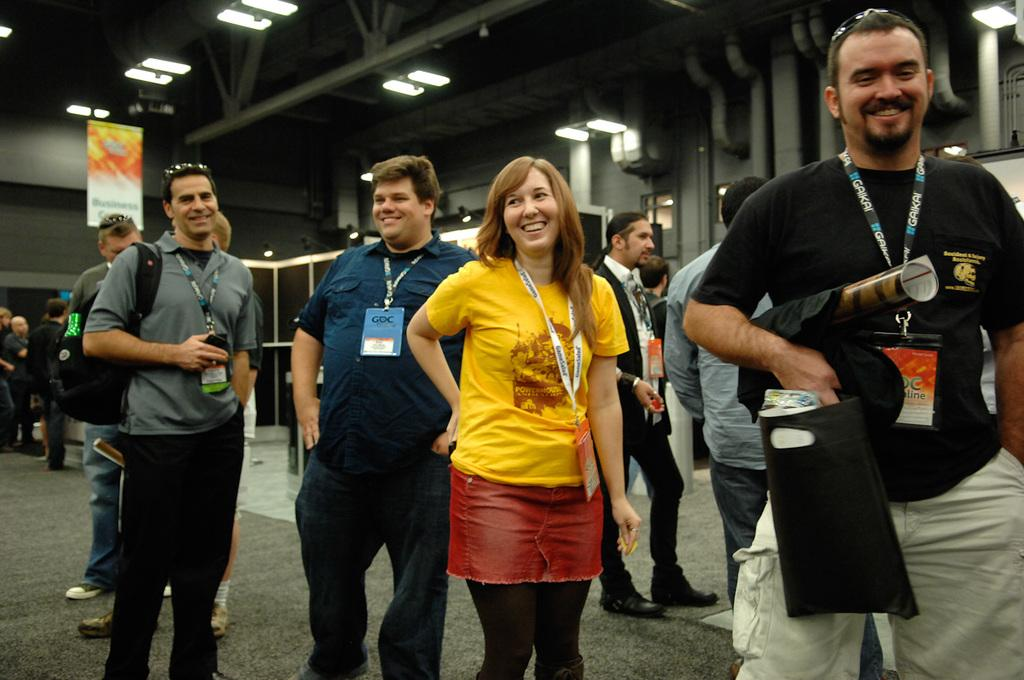What can be seen in the foreground of the picture? There are people standing in the foreground of the picture. What is located at the top of the image? There are lights and pipes at the top of the image. What is on the left side of the image? There is a hoarding on the left side of the image. What time of day is depicted in the image, and can you provide an example of a morning activity that might be happening? The time of day cannot be determined from the image, as there are no specific clues or indicators. Additionally, we cannot provide an example of a morning activity, as it is not relevant to the image. Are there any balloons visible in the image? No, there are no balloons present in the image. 